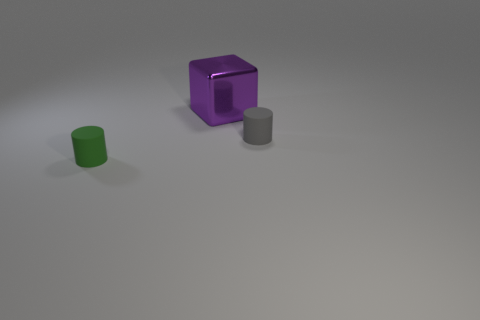Add 3 small green rubber cylinders. How many objects exist? 6 Subtract all cylinders. How many objects are left? 1 Add 3 tiny shiny balls. How many tiny shiny balls exist? 3 Subtract 0 gray balls. How many objects are left? 3 Subtract all red cylinders. Subtract all gray cubes. How many cylinders are left? 2 Subtract all blocks. Subtract all tiny green cylinders. How many objects are left? 1 Add 3 small green cylinders. How many small green cylinders are left? 4 